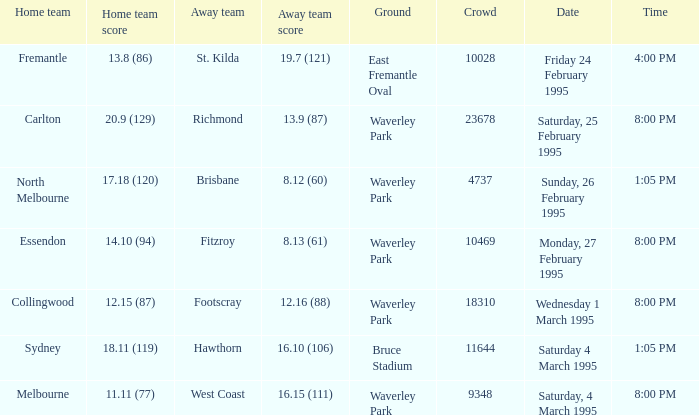On saturday, 4th of march 1995, what was the precise time? 1:05 PM. 